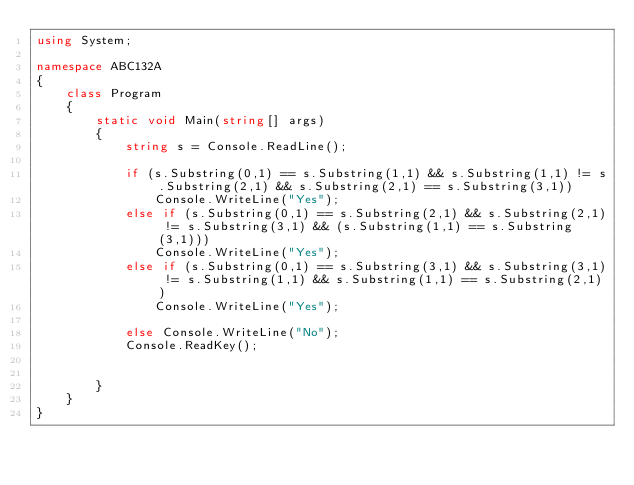<code> <loc_0><loc_0><loc_500><loc_500><_C#_>using System;

namespace ABC132A
{
    class Program
    {
        static void Main(string[] args)
        {
            string s = Console.ReadLine();

            if (s.Substring(0,1) == s.Substring(1,1) && s.Substring(1,1) != s.Substring(2,1) && s.Substring(2,1) == s.Substring(3,1))
                Console.WriteLine("Yes");
            else if (s.Substring(0,1) == s.Substring(2,1) && s.Substring(2,1) != s.Substring(3,1) && (s.Substring(1,1) == s.Substring(3,1)))
                Console.WriteLine("Yes");
            else if (s.Substring(0,1) == s.Substring(3,1) && s.Substring(3,1) != s.Substring(1,1) && s.Substring(1,1) == s.Substring(2,1))
                Console.WriteLine("Yes");

            else Console.WriteLine("No");
            Console.ReadKey();


        }
    }
}
</code> 